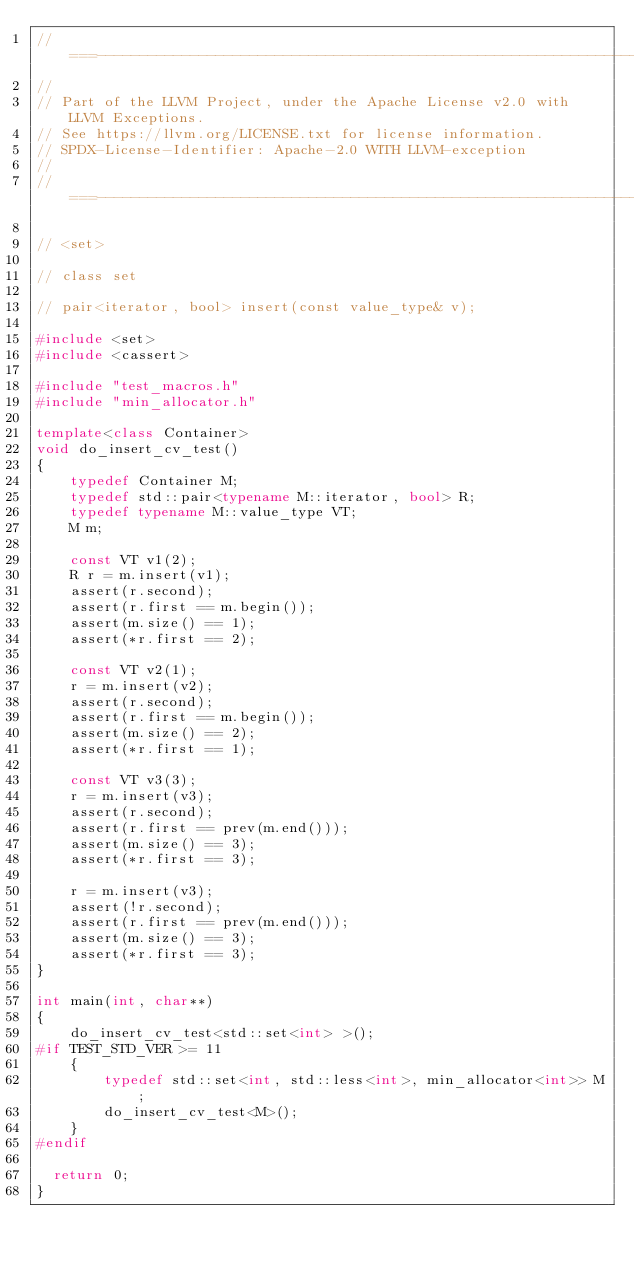Convert code to text. <code><loc_0><loc_0><loc_500><loc_500><_C++_>//===----------------------------------------------------------------------===//
//
// Part of the LLVM Project, under the Apache License v2.0 with LLVM Exceptions.
// See https://llvm.org/LICENSE.txt for license information.
// SPDX-License-Identifier: Apache-2.0 WITH LLVM-exception
//
//===----------------------------------------------------------------------===//

// <set>

// class set

// pair<iterator, bool> insert(const value_type& v);

#include <set>
#include <cassert>

#include "test_macros.h"
#include "min_allocator.h"

template<class Container>
void do_insert_cv_test()
{
    typedef Container M;
    typedef std::pair<typename M::iterator, bool> R;
    typedef typename M::value_type VT;
    M m;

    const VT v1(2);
    R r = m.insert(v1);
    assert(r.second);
    assert(r.first == m.begin());
    assert(m.size() == 1);
    assert(*r.first == 2);

    const VT v2(1);
    r = m.insert(v2);
    assert(r.second);
    assert(r.first == m.begin());
    assert(m.size() == 2);
    assert(*r.first == 1);

    const VT v3(3);
    r = m.insert(v3);
    assert(r.second);
    assert(r.first == prev(m.end()));
    assert(m.size() == 3);
    assert(*r.first == 3);

    r = m.insert(v3);
    assert(!r.second);
    assert(r.first == prev(m.end()));
    assert(m.size() == 3);
    assert(*r.first == 3);
}

int main(int, char**)
{
    do_insert_cv_test<std::set<int> >();
#if TEST_STD_VER >= 11
    {
        typedef std::set<int, std::less<int>, min_allocator<int>> M;
        do_insert_cv_test<M>();
    }
#endif

  return 0;
}
</code> 